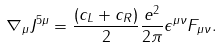Convert formula to latex. <formula><loc_0><loc_0><loc_500><loc_500>\nabla _ { \mu } J ^ { 5 \mu } & = \frac { ( c _ { L } + c _ { R } ) } { 2 } \frac { e ^ { 2 } } { 2 \pi } \epsilon ^ { \mu \nu } F _ { \mu \nu } .</formula> 